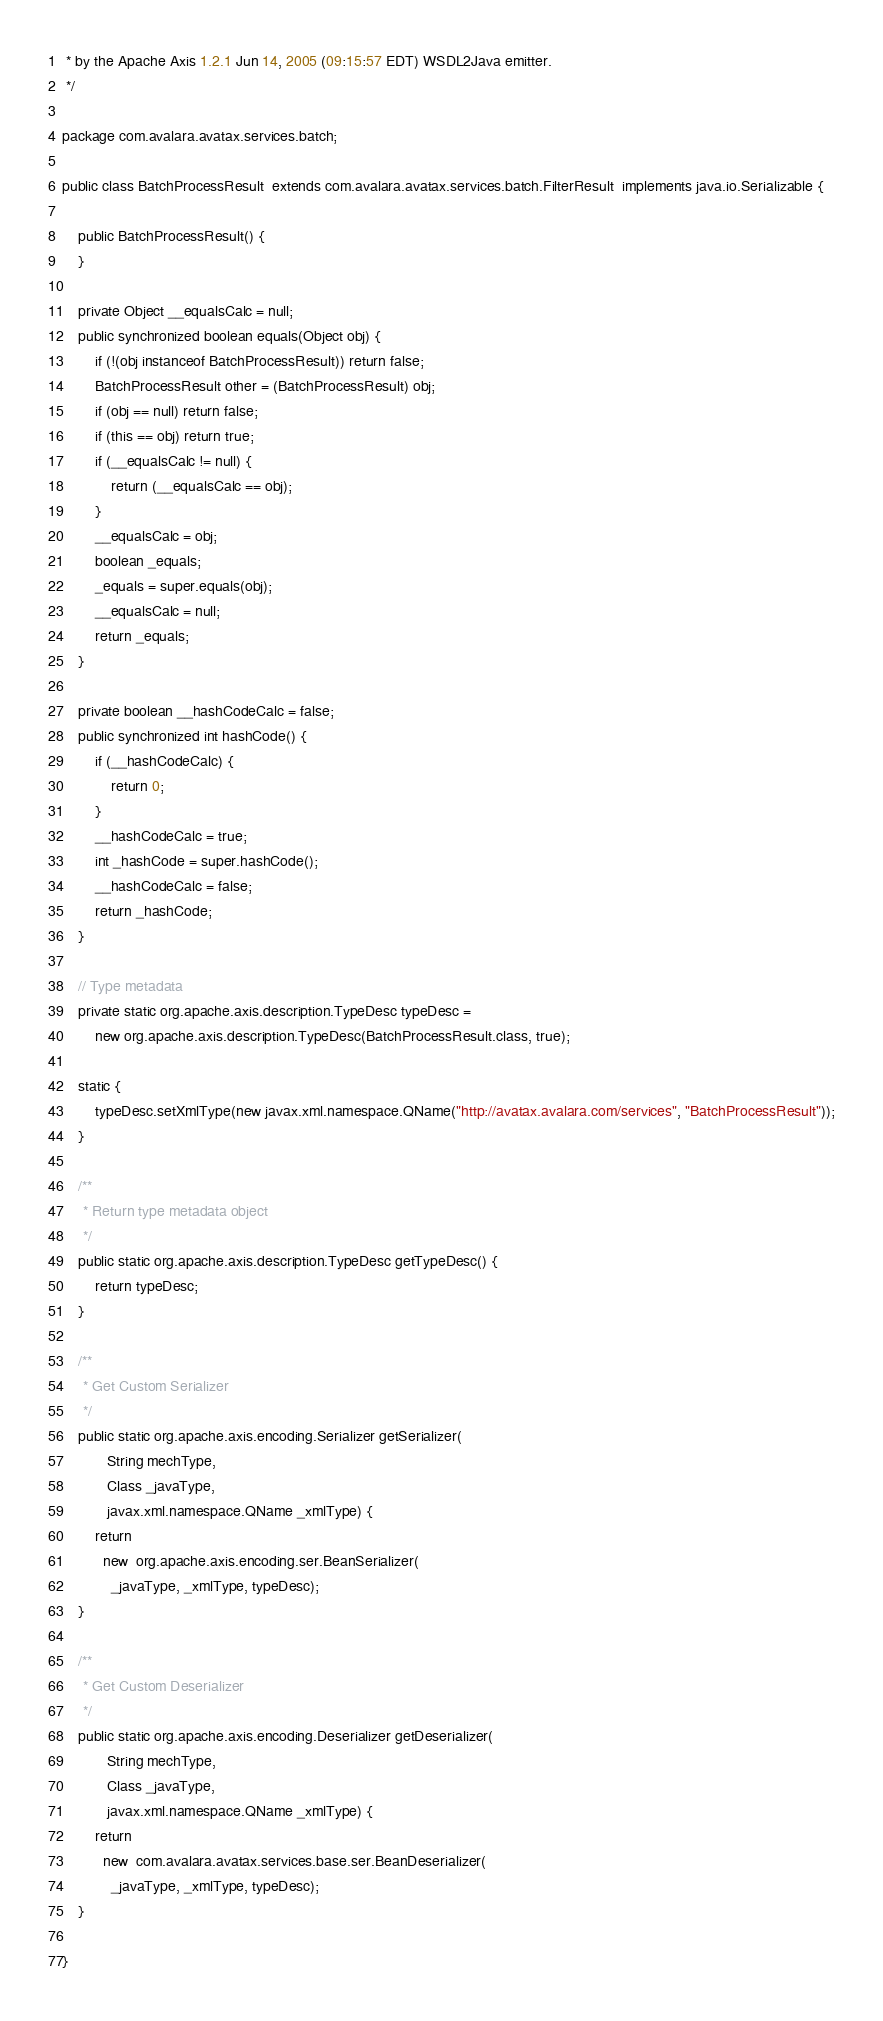Convert code to text. <code><loc_0><loc_0><loc_500><loc_500><_Java_> * by the Apache Axis 1.2.1 Jun 14, 2005 (09:15:57 EDT) WSDL2Java emitter.
 */

package com.avalara.avatax.services.batch;

public class BatchProcessResult  extends com.avalara.avatax.services.batch.FilterResult  implements java.io.Serializable {

    public BatchProcessResult() {
    }

    private Object __equalsCalc = null;
    public synchronized boolean equals(Object obj) {
        if (!(obj instanceof BatchProcessResult)) return false;
        BatchProcessResult other = (BatchProcessResult) obj;
        if (obj == null) return false;
        if (this == obj) return true;
        if (__equalsCalc != null) {
            return (__equalsCalc == obj);
        }
        __equalsCalc = obj;
        boolean _equals;
        _equals = super.equals(obj);
        __equalsCalc = null;
        return _equals;
    }

    private boolean __hashCodeCalc = false;
    public synchronized int hashCode() {
        if (__hashCodeCalc) {
            return 0;
        }
        __hashCodeCalc = true;
        int _hashCode = super.hashCode();
        __hashCodeCalc = false;
        return _hashCode;
    }

    // Type metadata
    private static org.apache.axis.description.TypeDesc typeDesc =
        new org.apache.axis.description.TypeDesc(BatchProcessResult.class, true);

    static {
        typeDesc.setXmlType(new javax.xml.namespace.QName("http://avatax.avalara.com/services", "BatchProcessResult"));
    }

    /**
     * Return type metadata object
     */
    public static org.apache.axis.description.TypeDesc getTypeDesc() {
        return typeDesc;
    }

    /**
     * Get Custom Serializer
     */
    public static org.apache.axis.encoding.Serializer getSerializer(
           String mechType,
           Class _javaType,
           javax.xml.namespace.QName _xmlType) {
        return 
          new  org.apache.axis.encoding.ser.BeanSerializer(
            _javaType, _xmlType, typeDesc);
    }

    /**
     * Get Custom Deserializer
     */
    public static org.apache.axis.encoding.Deserializer getDeserializer(
           String mechType,
           Class _javaType,
           javax.xml.namespace.QName _xmlType) {
        return 
          new  com.avalara.avatax.services.base.ser.BeanDeserializer(
            _javaType, _xmlType, typeDesc);
    }

}
</code> 